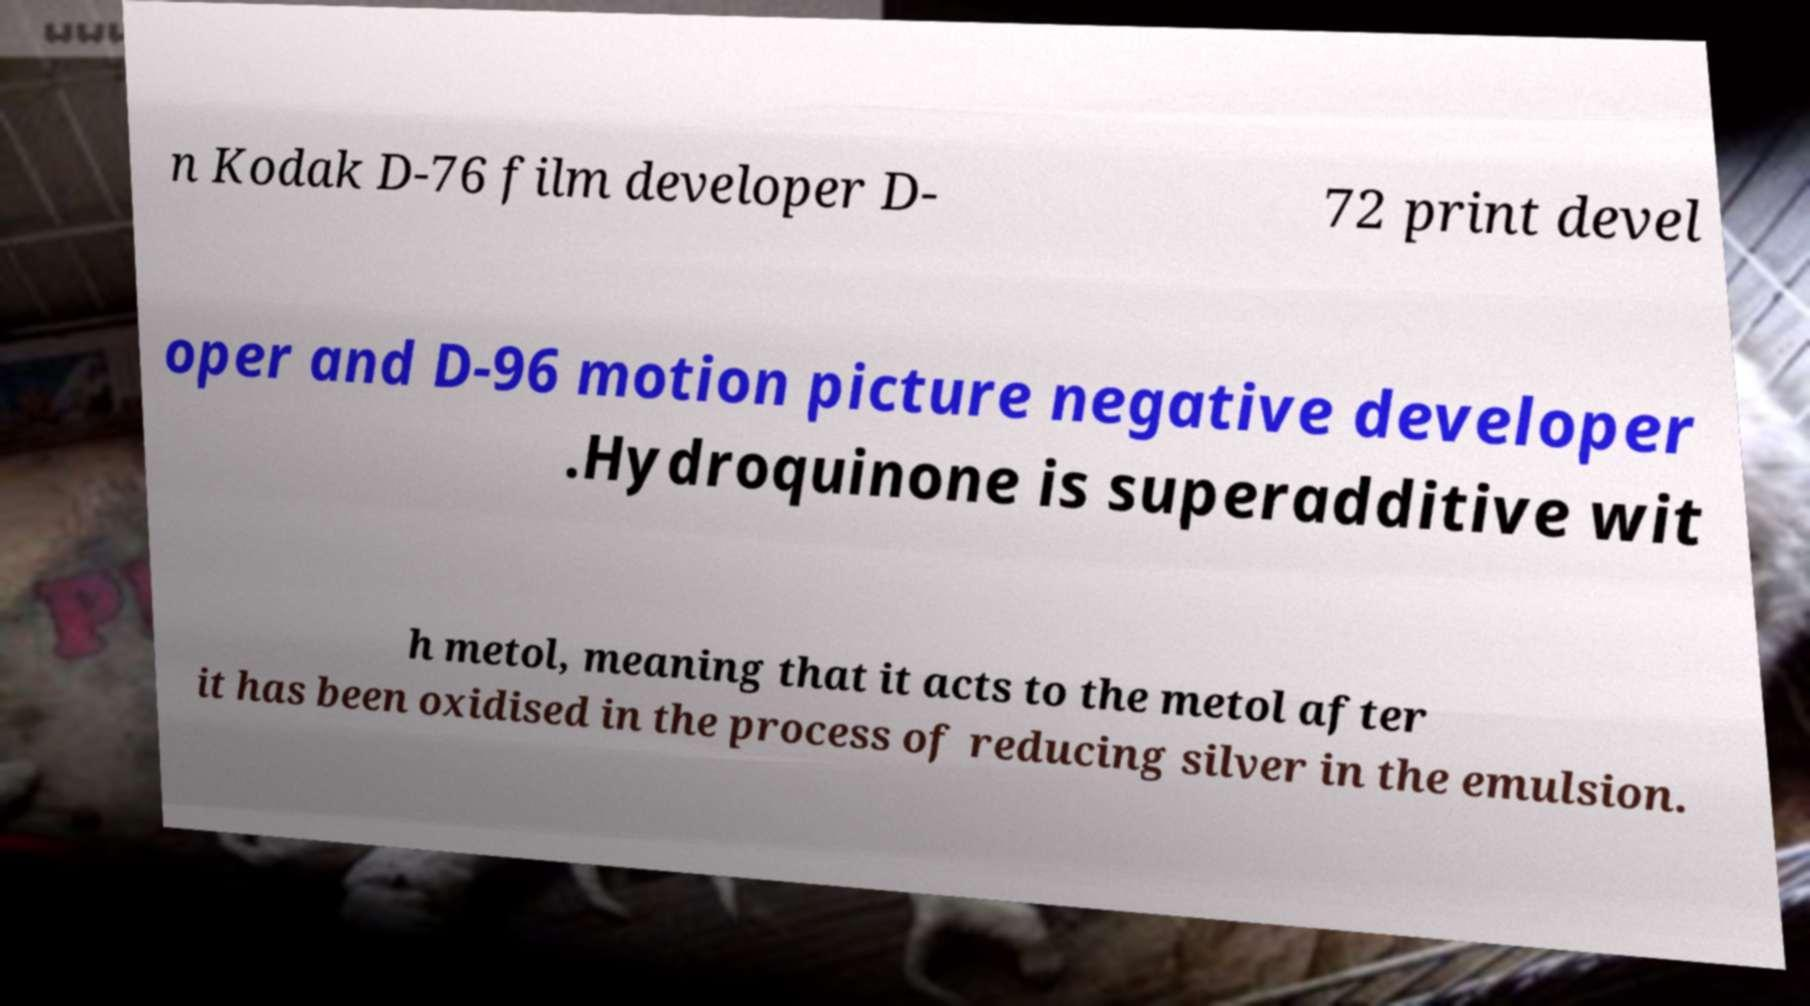Please identify and transcribe the text found in this image. n Kodak D-76 film developer D- 72 print devel oper and D-96 motion picture negative developer .Hydroquinone is superadditive wit h metol, meaning that it acts to the metol after it has been oxidised in the process of reducing silver in the emulsion. 